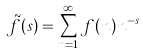Convert formula to latex. <formula><loc_0><loc_0><loc_500><loc_500>\tilde { f } ( s ) = \sum _ { n = 1 } ^ { \infty } f ( n ) n ^ { - s }</formula> 